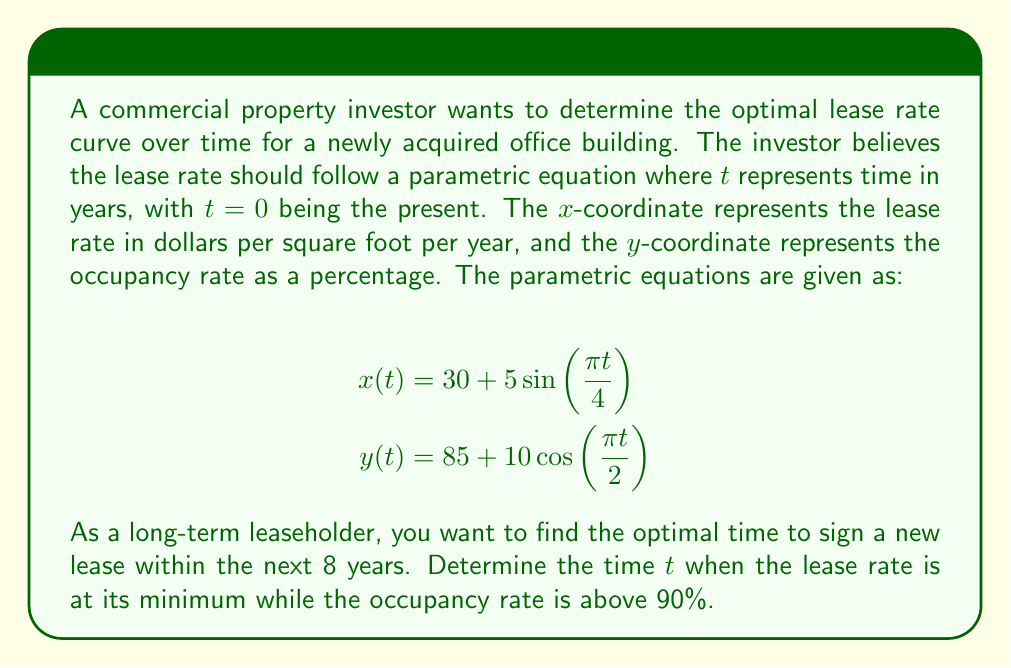Can you solve this math problem? To solve this problem, we need to follow these steps:

1) First, we need to find the minimum lease rate within the given time frame (0 ≤ t ≤ 8).
   The lease rate is given by $x(t) = 30 + 5\sin(\frac{\pi t}{4})$.
   This function has a period of 8 years and reaches its minimum when $\sin(\frac{\pi t}{4}) = -1$.
   This occurs when $\frac{\pi t}{4} = \frac{3\pi}{2}$, or $t = 6$.

2) Next, we need to check if the occupancy rate is above 90% at t = 6.
   The occupancy rate is given by $y(t) = 85 + 10\cos(\frac{\pi t}{2})$.
   At t = 6:
   $y(6) = 85 + 10\cos(\frac{6\pi}{2}) = 85 + 10\cos(3\pi) = 85 + 10 = 95$

3) Since 95% > 90%, the occupancy rate condition is satisfied at t = 6.

4) To confirm this is the only solution within the given time frame, we can check the other minimum point at t = 2:
   $y(2) = 85 + 10\cos(\pi) = 85 - 10 = 75$
   This doesn't satisfy the occupancy rate condition.

5) The minimum lease rate at t = 6 is:
   $x(6) = 30 + 5\sin(\frac{6\pi}{4}) = 30 + 5(-1) = 25$ dollars per square foot per year.
Answer: The optimal time to sign a new lease is at $t = 6$ years from now, when the lease rate will be $25 per square foot per year and the occupancy rate will be 95%. 